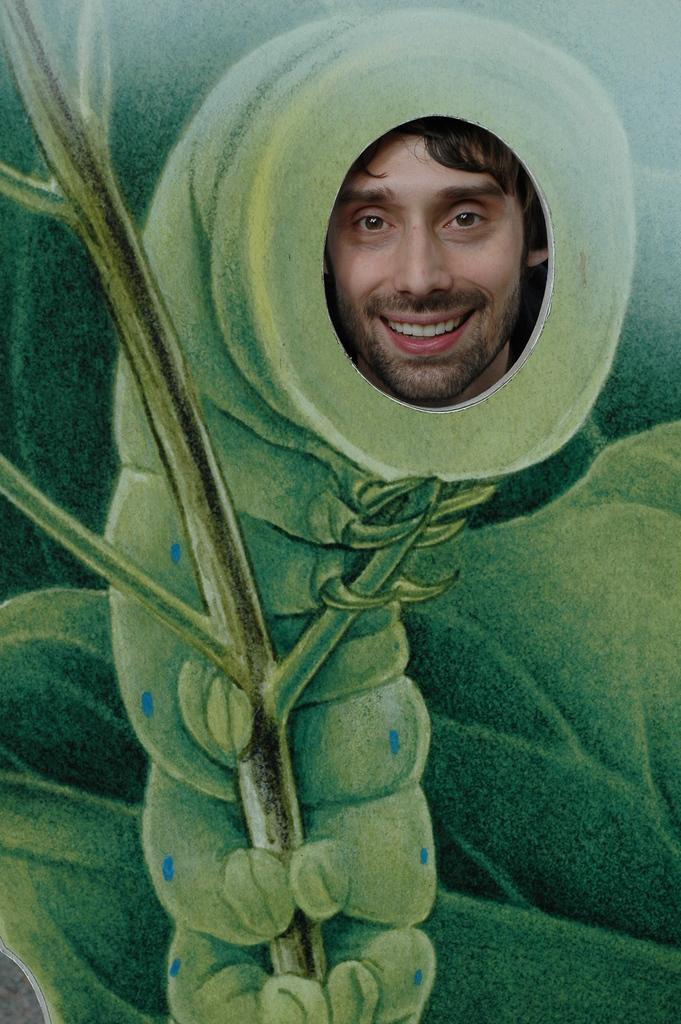What is the main subject of the image? There is a person in the image. Where is the person located in the image? The person is watching from a painted poster. Can you describe the location of the painted poster in the image? The painted poster is in the middle of the image. How does the fog affect the person's view in the image? There is no fog present in the image, so it does not affect the person's view. What type of mouth is visible on the person in the image? The person in the image is a painted poster, so there is no actual mouth visible. 